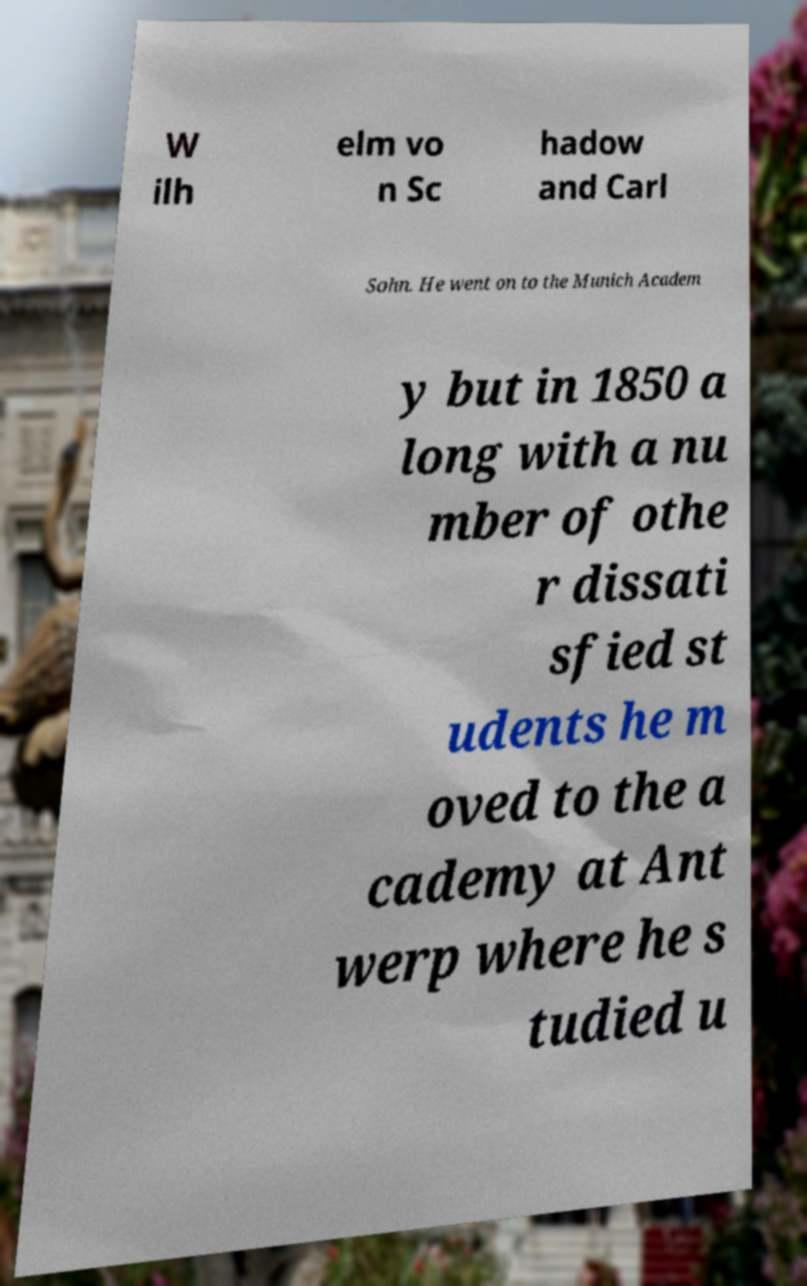Can you accurately transcribe the text from the provided image for me? W ilh elm vo n Sc hadow and Carl Sohn. He went on to the Munich Academ y but in 1850 a long with a nu mber of othe r dissati sfied st udents he m oved to the a cademy at Ant werp where he s tudied u 